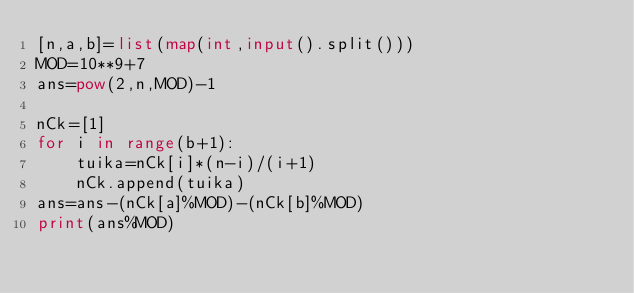Convert code to text. <code><loc_0><loc_0><loc_500><loc_500><_Python_>[n,a,b]=list(map(int,input().split()))
MOD=10**9+7
ans=pow(2,n,MOD)-1

nCk=[1]
for i in range(b+1):
    tuika=nCk[i]*(n-i)/(i+1)
    nCk.append(tuika)
ans=ans-(nCk[a]%MOD)-(nCk[b]%MOD)
print(ans%MOD)
</code> 